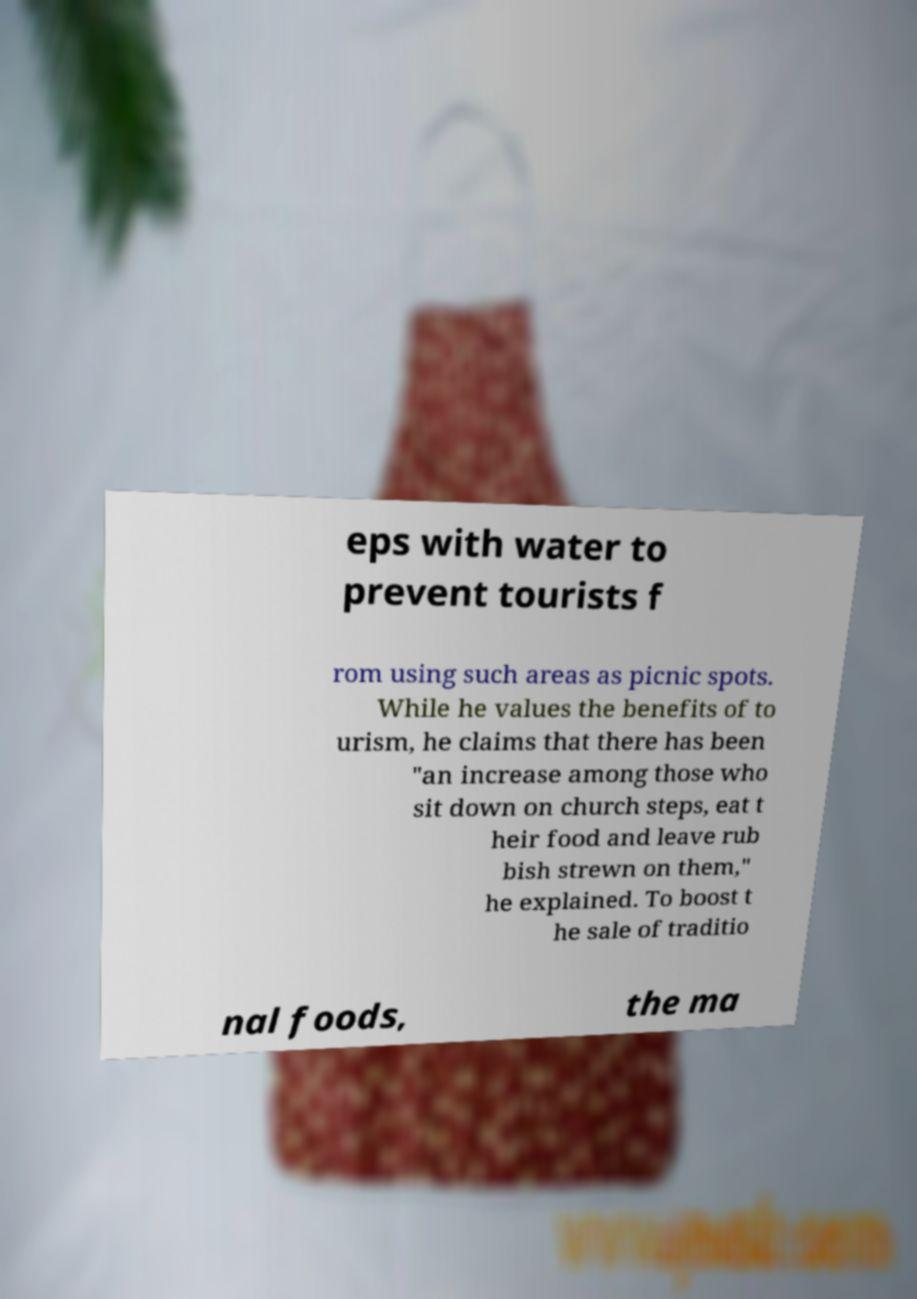Please read and relay the text visible in this image. What does it say? eps with water to prevent tourists f rom using such areas as picnic spots. While he values the benefits of to urism, he claims that there has been "an increase among those who sit down on church steps, eat t heir food and leave rub bish strewn on them," he explained. To boost t he sale of traditio nal foods, the ma 